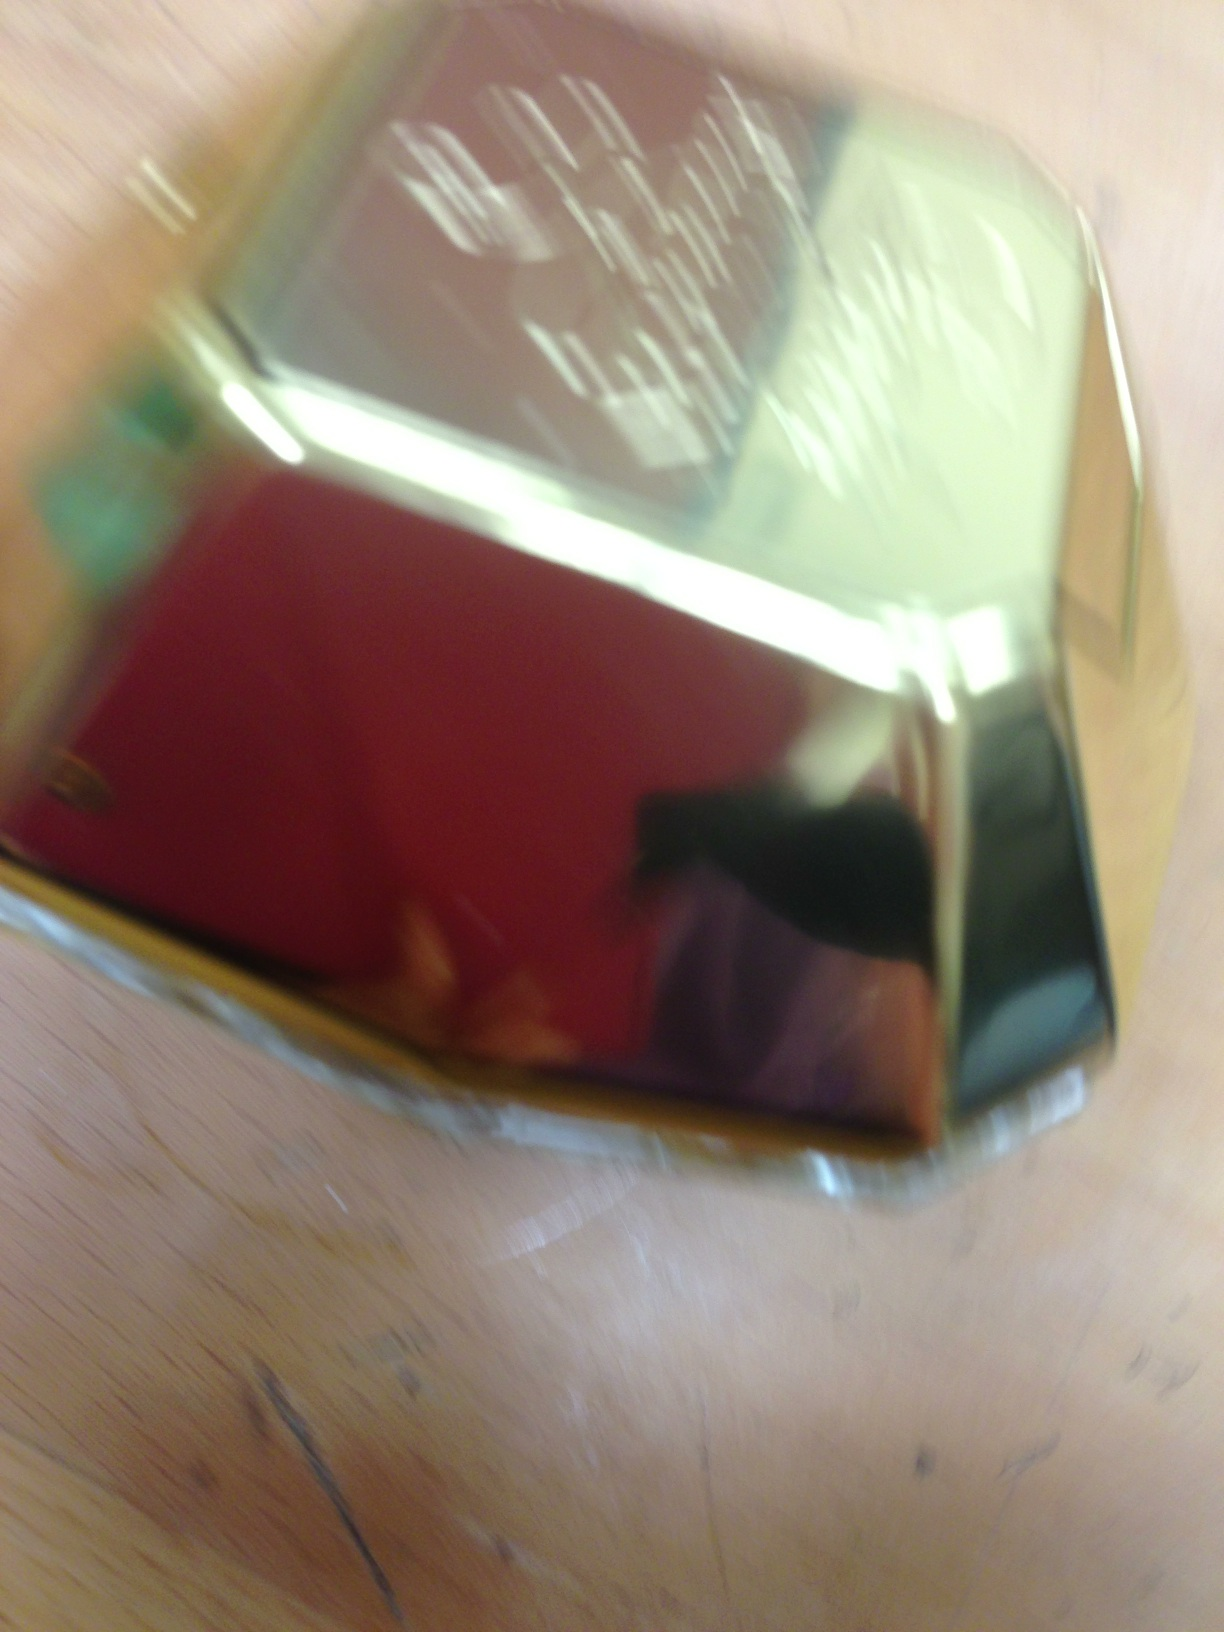Pretend that this perfume bottle is a mystical object. What powers does it contain? Behold, this isn’t just a perfume bottle; it's an artifact of mystical origins! Its fragrance has the power to transport the wearer’s mind to far-off realms, creating vivid, lifelike illusions. The scent can also influence emotions, instilling confidence, calm, or even evoking deep memories hidden within one’s soul. Handle with care, for its powers can enchant and bewitch anyone who comes near. 